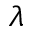Convert formula to latex. <formula><loc_0><loc_0><loc_500><loc_500>\lambda</formula> 